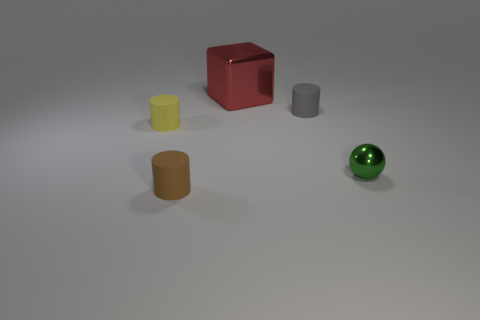What number of cyan metallic balls have the same size as the gray thing? Upon reviewing the image, there are no cyan metallic balls present at all, which means the number of cyan metallic balls that have the same size as the gray thing is zero. It is important to note that there is only one metallic ball in the image which is green, not cyan, and it differs in size from the cylindrical gray object. 